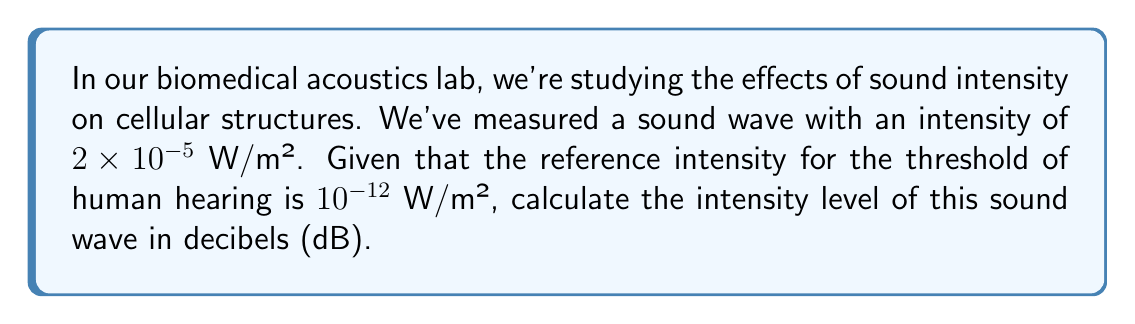Show me your answer to this math problem. Let's approach this step-by-step:

1) The formula for calculating sound intensity level (IL) in decibels is:

   $$ IL = 10 \log_{10} \left(\frac{I}{I_0}\right) \text{ dB} $$

   Where:
   - $I$ is the intensity of the sound wave
   - $I_0$ is the reference intensity (threshold of hearing)

2) We're given:
   - $I = 2 \times 10^{-5}$ W/m²
   - $I_0 = 10^{-12}$ W/m²

3) Let's substitute these values into our equation:

   $$ IL = 10 \log_{10} \left(\frac{2 \times 10^{-5}}{10^{-12}}\right) \text{ dB} $$

4) Simplify inside the parentheses:

   $$ IL = 10 \log_{10} (2 \times 10^7) \text{ dB} $$

5) Use the logarithm property $\log(a \times 10^n) = \log(a) + n$:

   $$ IL = 10 (\log_{10}(2) + 7) \text{ dB} $$

6) Calculate $\log_{10}(2)$ ≈ 0.301:

   $$ IL = 10 (0.301 + 7) \text{ dB} $$

7) Simplify:

   $$ IL = 10 (7.301) = 73.01 \text{ dB} $$

8) Round to two decimal places:

   $$ IL = 73.01 \text{ dB} $$
Answer: 73.01 dB 